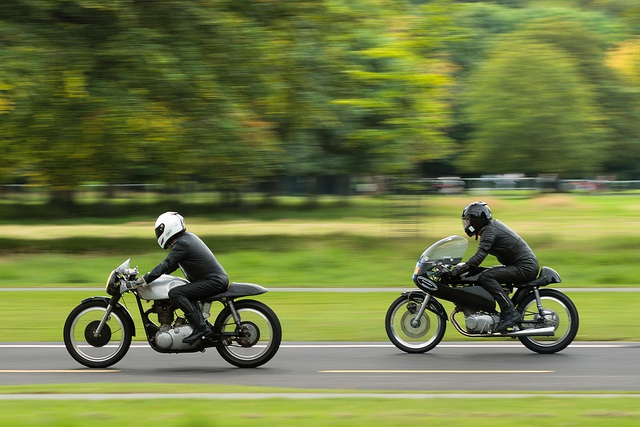Describe the objects in this image and their specific colors. I can see motorcycle in black, darkgray, gray, and olive tones, motorcycle in black, gray, olive, and darkgray tones, people in black, gray, darkgray, and purple tones, and people in black, gray, white, and darkgray tones in this image. 